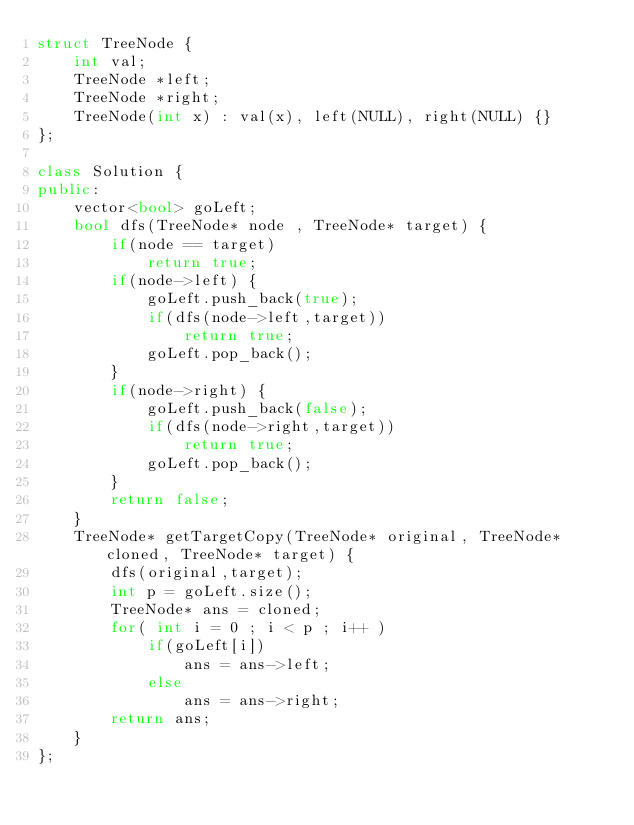Convert code to text. <code><loc_0><loc_0><loc_500><loc_500><_C++_>struct TreeNode {
    int val;
    TreeNode *left;
    TreeNode *right;
    TreeNode(int x) : val(x), left(NULL), right(NULL) {}
};

class Solution {
public:
    vector<bool> goLeft;
    bool dfs(TreeNode* node , TreeNode* target) {
        if(node == target)
            return true;
        if(node->left) {
            goLeft.push_back(true);
            if(dfs(node->left,target))
                return true;
            goLeft.pop_back();
        }
        if(node->right) {
            goLeft.push_back(false);
            if(dfs(node->right,target))
                return true;
            goLeft.pop_back();
        }
        return false;
    }
    TreeNode* getTargetCopy(TreeNode* original, TreeNode* cloned, TreeNode* target) {
        dfs(original,target);
        int p = goLeft.size();
        TreeNode* ans = cloned;
        for( int i = 0 ; i < p ; i++ )
            if(goLeft[i])
                ans = ans->left;
            else
                ans = ans->right;
        return ans;
    }
};</code> 